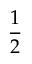Convert formula to latex. <formula><loc_0><loc_0><loc_500><loc_500>\frac { 1 } { 2 }</formula> 